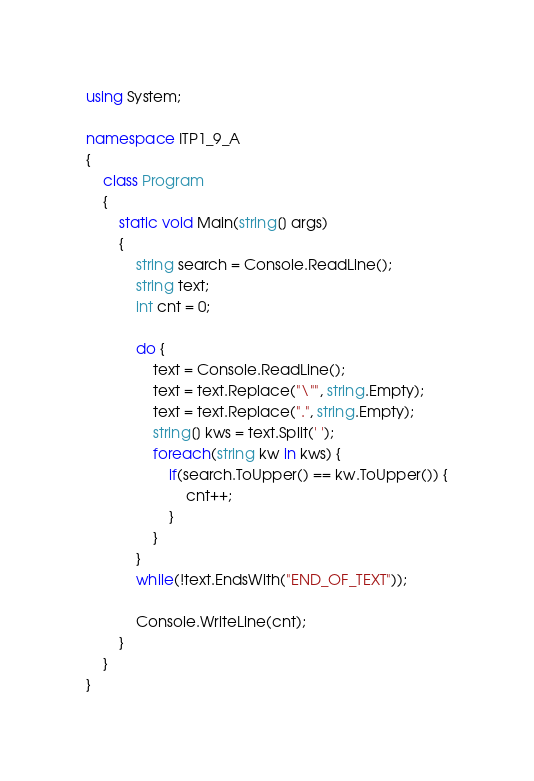Convert code to text. <code><loc_0><loc_0><loc_500><loc_500><_C#_>using System;

namespace ITP1_9_A
{
	class Program
	{
		static void Main(string[] args)
		{
			string search = Console.ReadLine();
			string text;
			int cnt = 0;

			do {
				text = Console.ReadLine();
				text = text.Replace("\"", string.Empty);
				text = text.Replace(".", string.Empty);
				string[] kws = text.Split(' ');
				foreach(string kw in kws) {
					if(search.ToUpper() == kw.ToUpper()) {
						cnt++;
					}
				}
			}
			while(!text.EndsWith("END_OF_TEXT"));

			Console.WriteLine(cnt);
		}
	}
}

</code> 